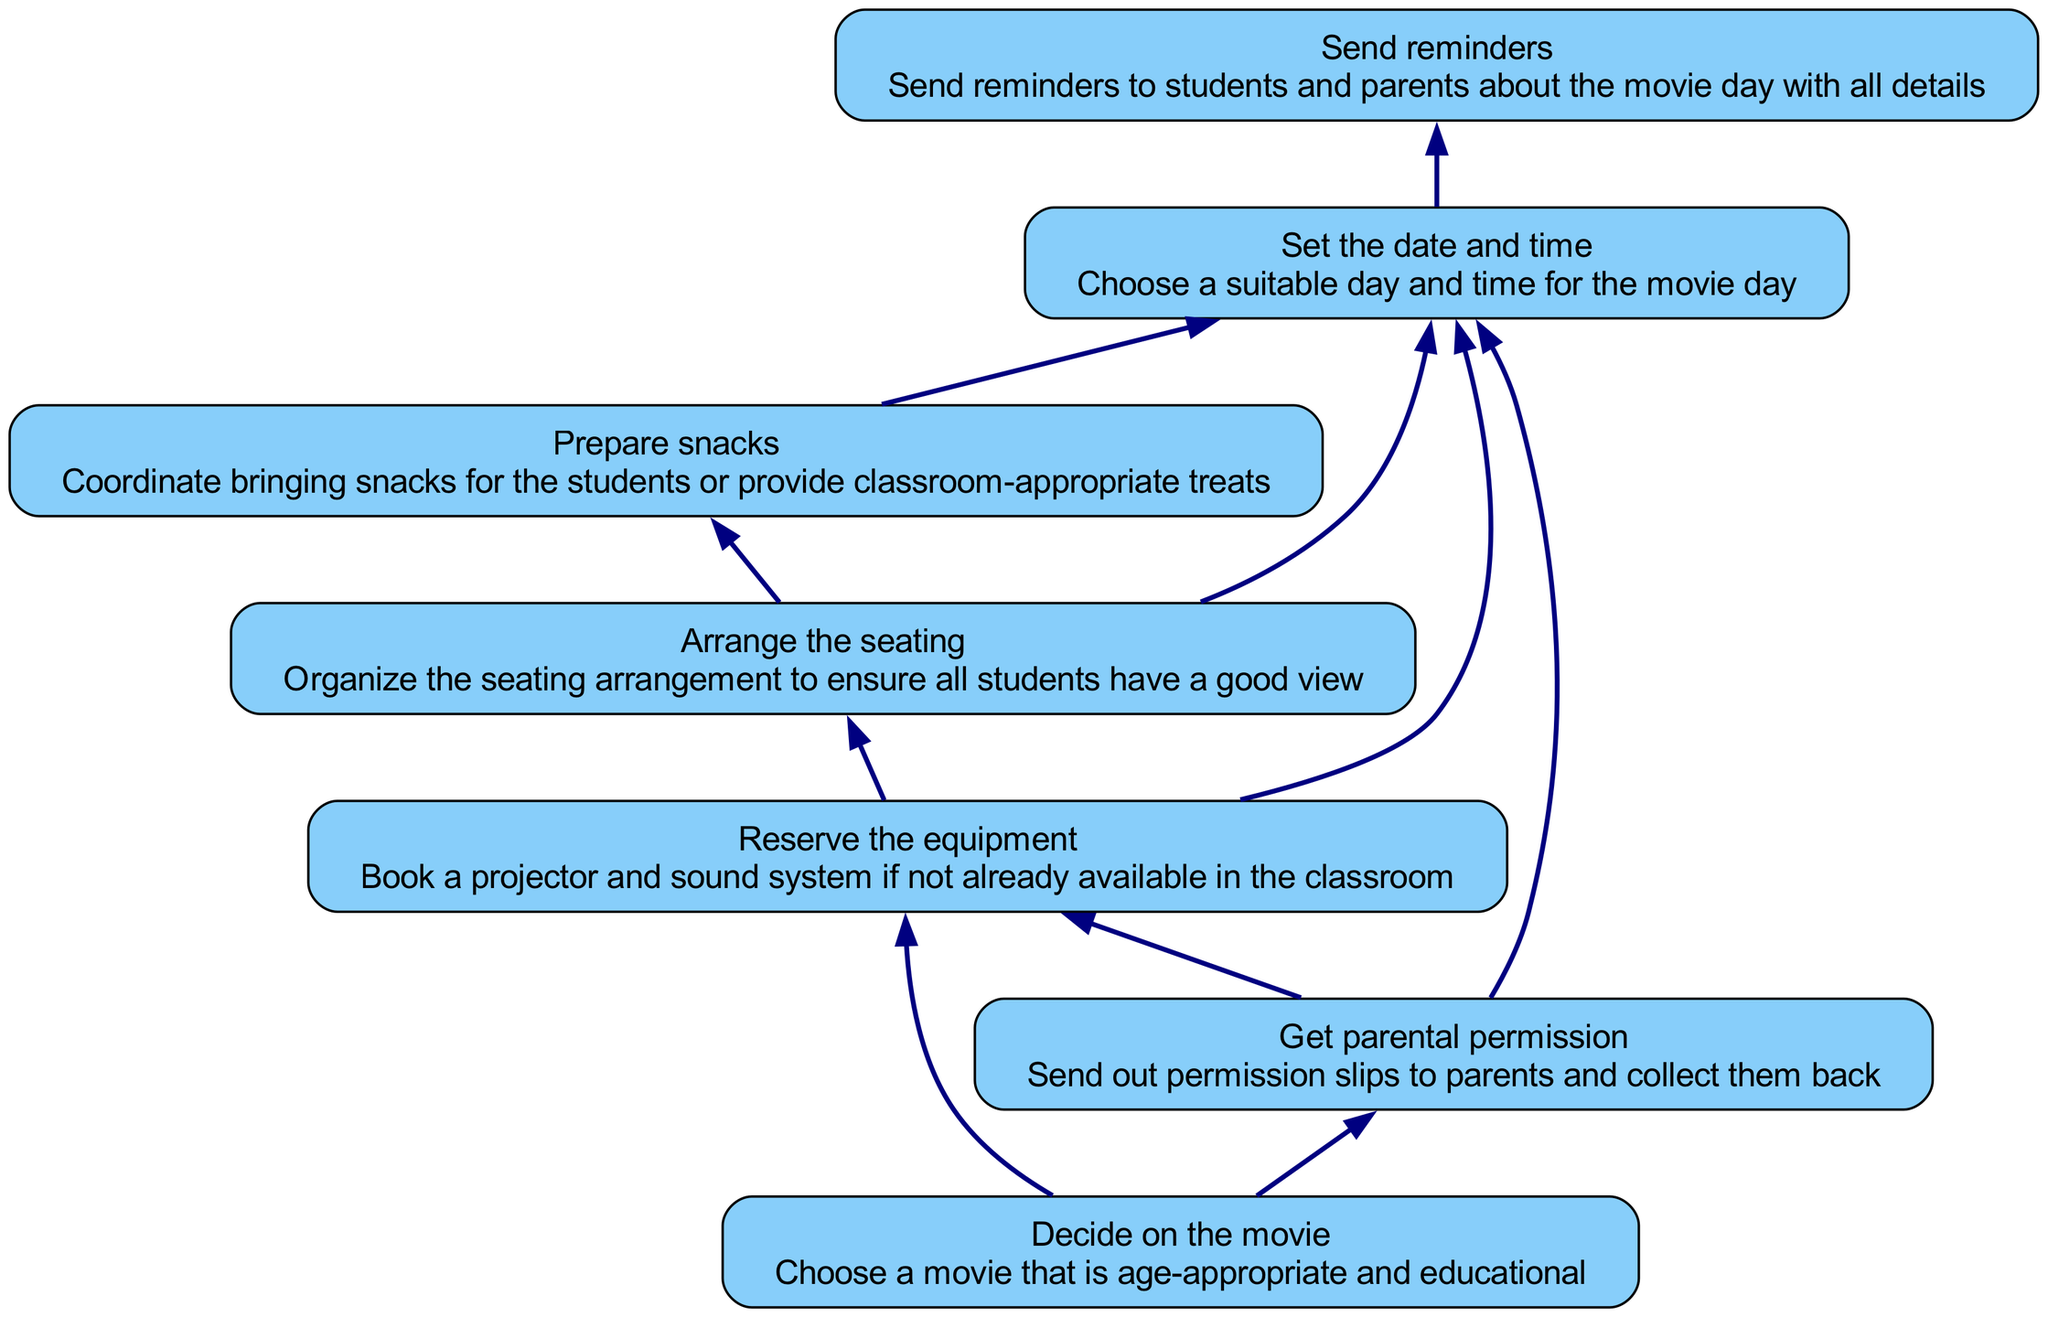What is the first step in organizing a classroom movie day? The first step is "Decide on the movie". This node has no dependencies, indicating it can be initiated independently and sets the foundation for the following actions.
Answer: Decide on the movie How many total steps are involved in the flow chart? By counting the individual nodes present in the chart, which represent the steps, we find there are seven distinct steps listed.
Answer: Seven What step comes after reserving the equipment? The next step after "Reserve the equipment" is "Arrange the seating". This is indicated by the directed edge flowing from the equipment reservation node to the seating arrangement node.
Answer: Arrange the seating Which steps require parental permission before proceeding? The steps that require "Get parental permission" are "Reserve the equipment" and "Set the date and time". Both steps are dependent on the completion of obtaining parental permission as indicated by their directed edges.
Answer: Reserve the equipment, Set the date and time What is the last step in this flow chart? The final step of the flow chart is "Send reminders". This is shown at the top of the flow, indicating it can only occur after all previous steps are completed.
Answer: Send reminders If a movie is chosen, what other step must be completed before reserving the equipment? Once a movie is chosen, the additional step that must be completed before reserving equipment is obtaining parental permission. This relationship is illustrated by the directional flow from "Decide on the movie" to "Get parental permission".
Answer: Get parental permission What action follows after arranging the seating? After arranging the seating, the next action to take is "Prepare snacks". This flow is depicted by the directed edge indicating the sequential dependency of seating arrangement on snack preparation.
Answer: Prepare snacks How many dependencies does "Set the date and time" have? The step "Set the date and time" has four dependencies that need to be satisfied beforehand: "Get parental permission", "Reserve the equipment", "Arrange the seating", and "Prepare snacks", as shown by the incoming edges.
Answer: Four 